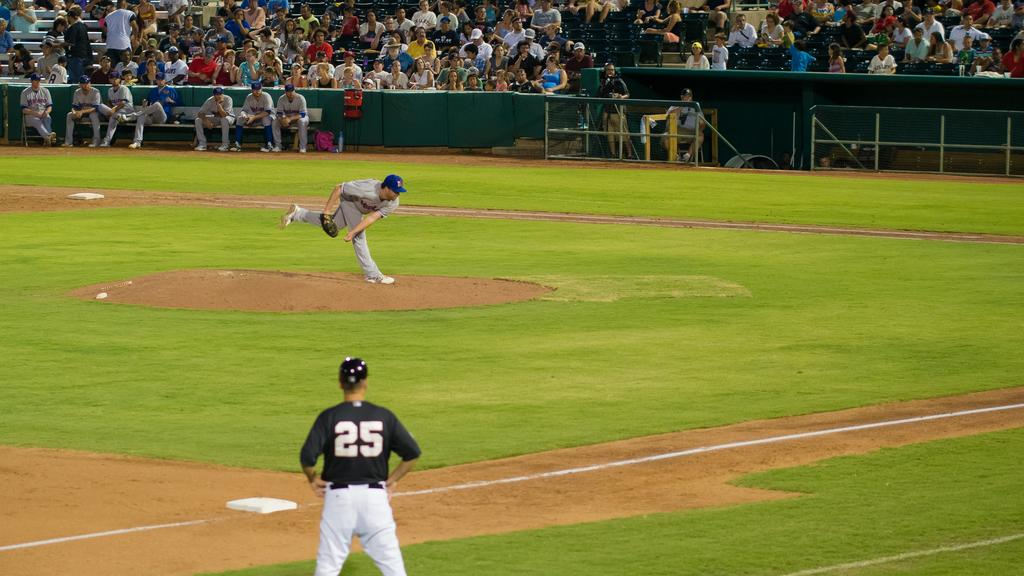<image>
Describe the image concisely. Number 25 watches the pitcher throw the baseball. 